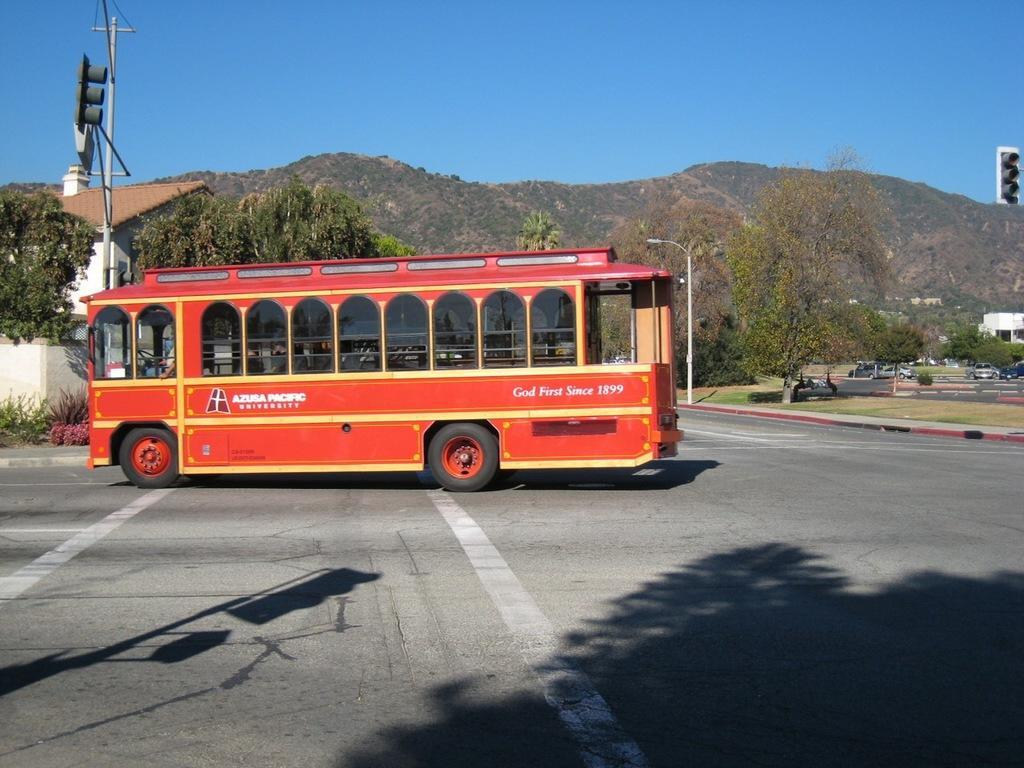Could you give a brief overview of what you see in this image? There is a bus which is red in color is on the road and there are trees and mountains in the background. 